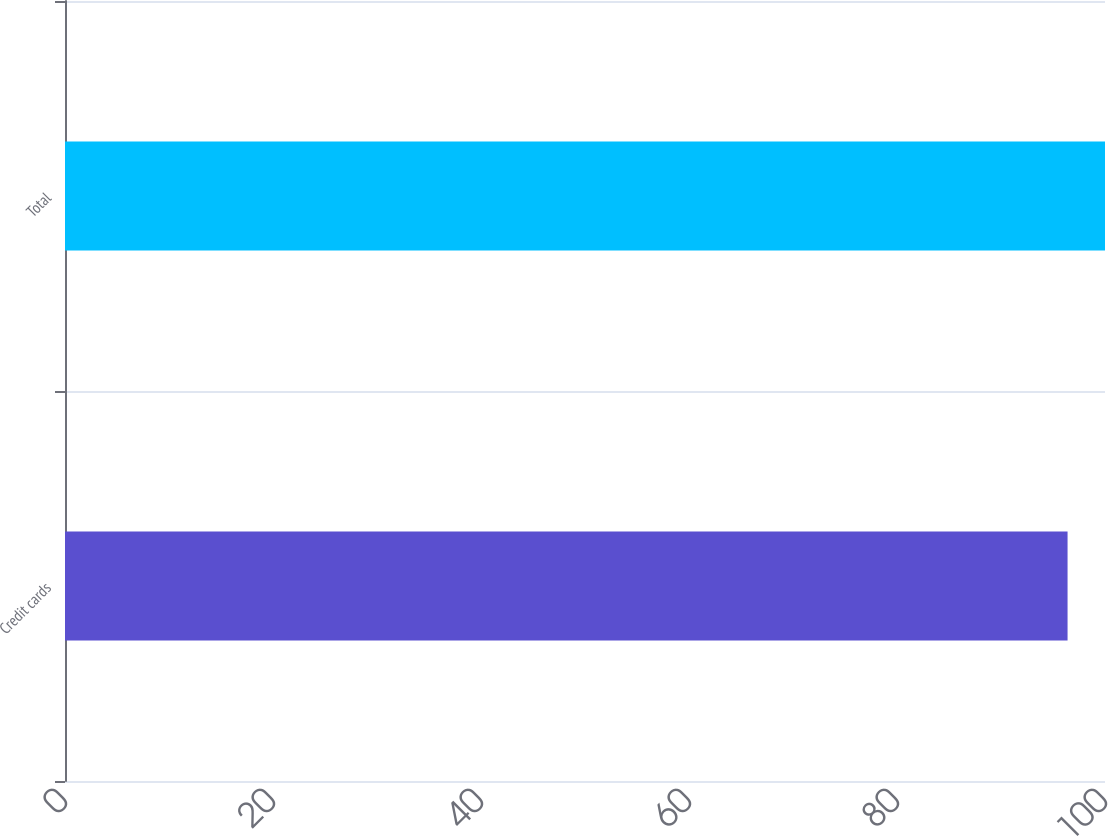Convert chart to OTSL. <chart><loc_0><loc_0><loc_500><loc_500><bar_chart><fcel>Credit cards<fcel>Total<nl><fcel>96.4<fcel>100<nl></chart> 